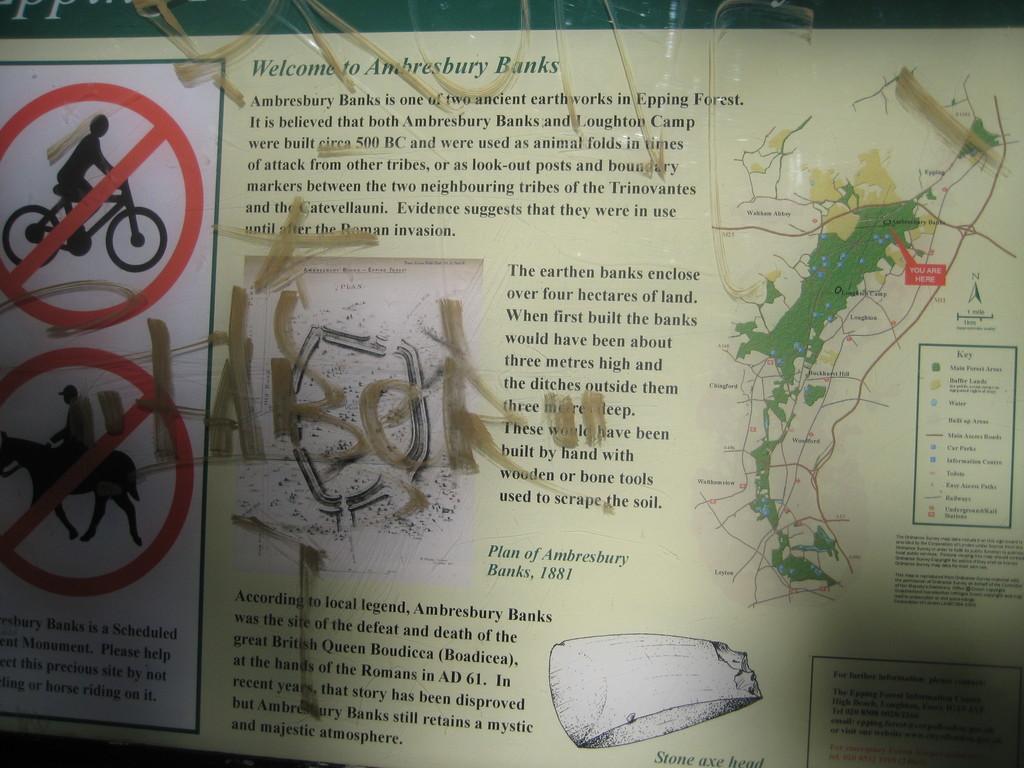What is after welcome to?
Your response must be concise. Ambresbury banks. Is there graffiti on the sign?
Provide a short and direct response. Yes. 